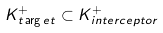<formula> <loc_0><loc_0><loc_500><loc_500>K ^ { + } _ { t \arg e t } \subset K ^ { + } _ { i n t e r c e p t o r }</formula> 